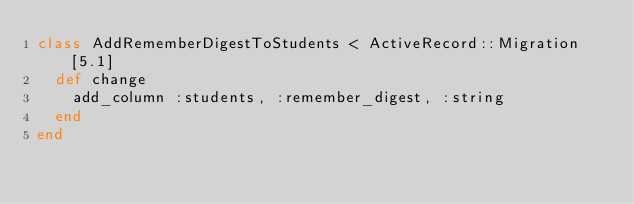Convert code to text. <code><loc_0><loc_0><loc_500><loc_500><_Ruby_>class AddRememberDigestToStudents < ActiveRecord::Migration[5.1]
  def change
    add_column :students, :remember_digest, :string
  end
end
</code> 